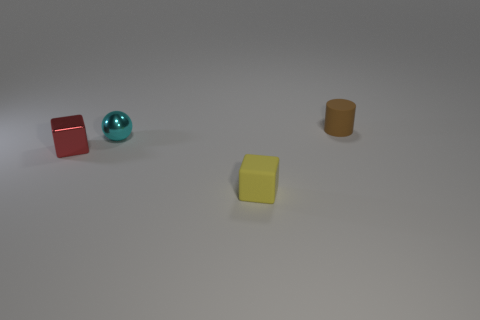There is a object in front of the red thing; is it the same color as the small block that is left of the matte cube?
Give a very brief answer. No. There is a tiny cyan metallic object; are there any shiny things behind it?
Provide a succinct answer. No. There is a small object that is both to the right of the tiny cyan metallic object and left of the brown matte cylinder; what is it made of?
Offer a terse response. Rubber. Do the tiny object in front of the red block and the tiny sphere have the same material?
Your response must be concise. No. What is the small red object made of?
Offer a very short reply. Metal. What size is the cube that is to the right of the sphere?
Keep it short and to the point. Small. Is there any other thing of the same color as the metallic ball?
Make the answer very short. No. Are there any rubber cylinders that are in front of the tiny matte object on the right side of the yellow block that is in front of the tiny sphere?
Give a very brief answer. No. There is a thing right of the small matte block; does it have the same color as the small sphere?
Your answer should be very brief. No. How many spheres are tiny red things or tiny blue matte things?
Keep it short and to the point. 0. 